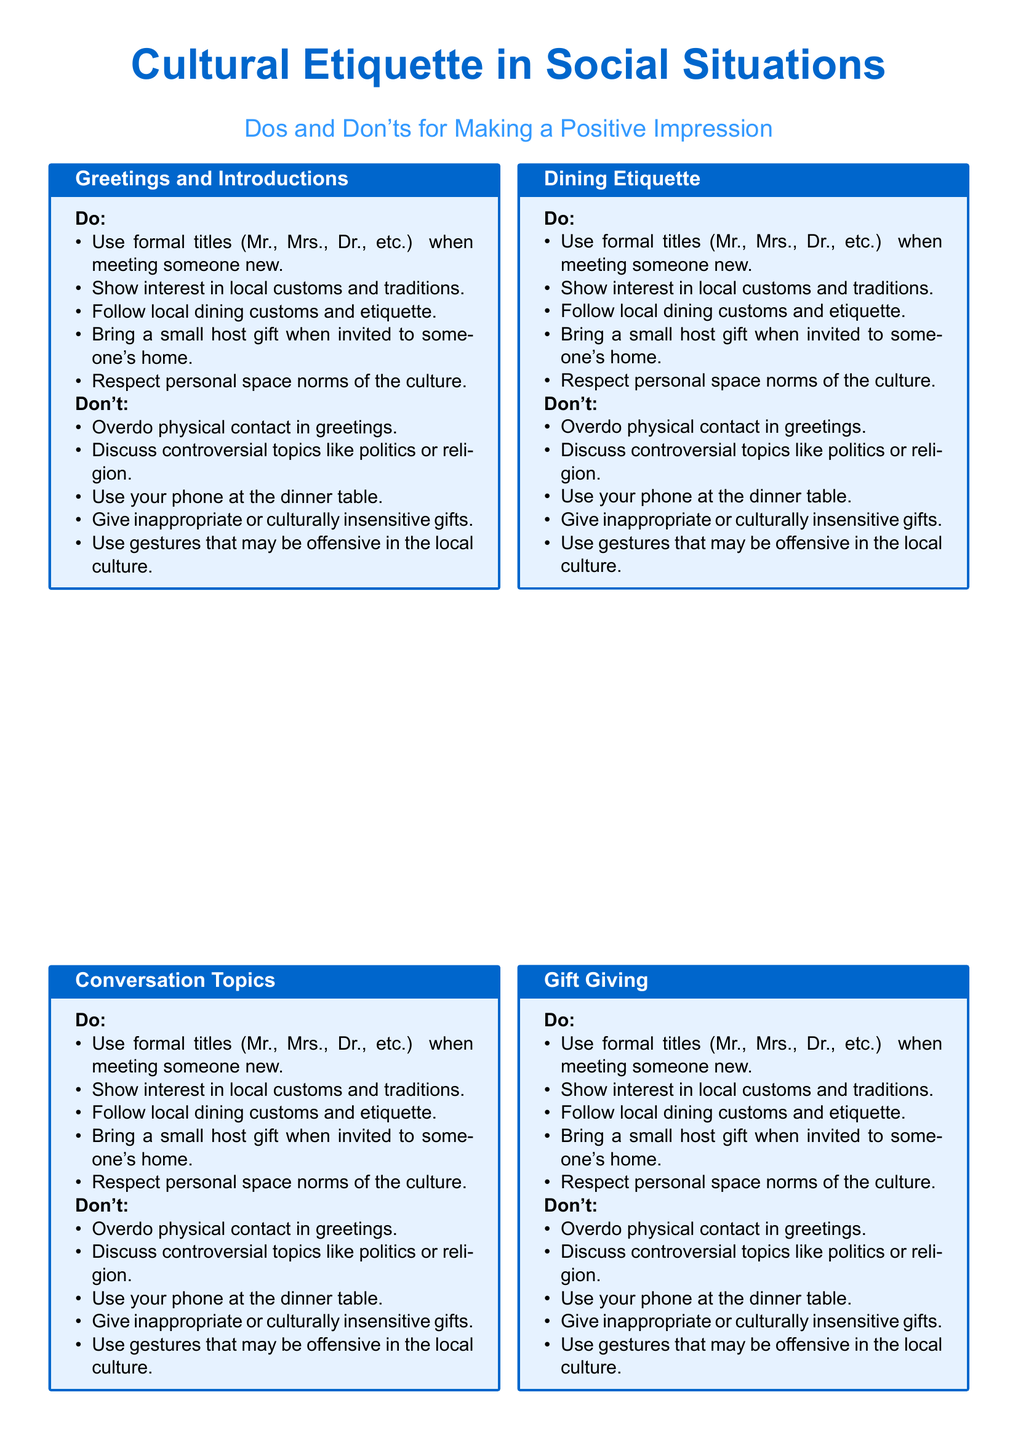What should you use when meeting someone new? The document suggests using formal titles (Mr., Mrs., Dr., etc.) when meeting someone new.
Answer: formal titles What is a polite thing to bring when invited to someone's home? According to the document, bringing a small host gift is appropriate when invited to someone's home.
Answer: small host gift Which controversial topics should be avoided in conversation? The document lists discussing politics or religion as controversial topics to avoid.
Answer: politics or religion What is one of the dining etiquette practices mentioned? Following local dining customs and etiquette is identified as a key practice in the document.
Answer: local dining customs What is suggested regarding personal space? The document emphasizes respecting personal space norms of the culture.
Answer: respect personal space norms What is the primary goal of researching local customs? The document states that the purpose of researching local customs is to make a positive impression.
Answer: make a positive impression How many main sections are covered in the etiquette fact sheet? There are five main sections covered in the fact sheet.
Answer: five What gesture should be avoided in the local culture? The document warns against using gestures that may be offensive in the local culture.
Answer: offensive gestures What does the fact sheet suggest about phone usage at the dinner table? The document advises not to use your phone at the dinner table.
Answer: not use your phone 